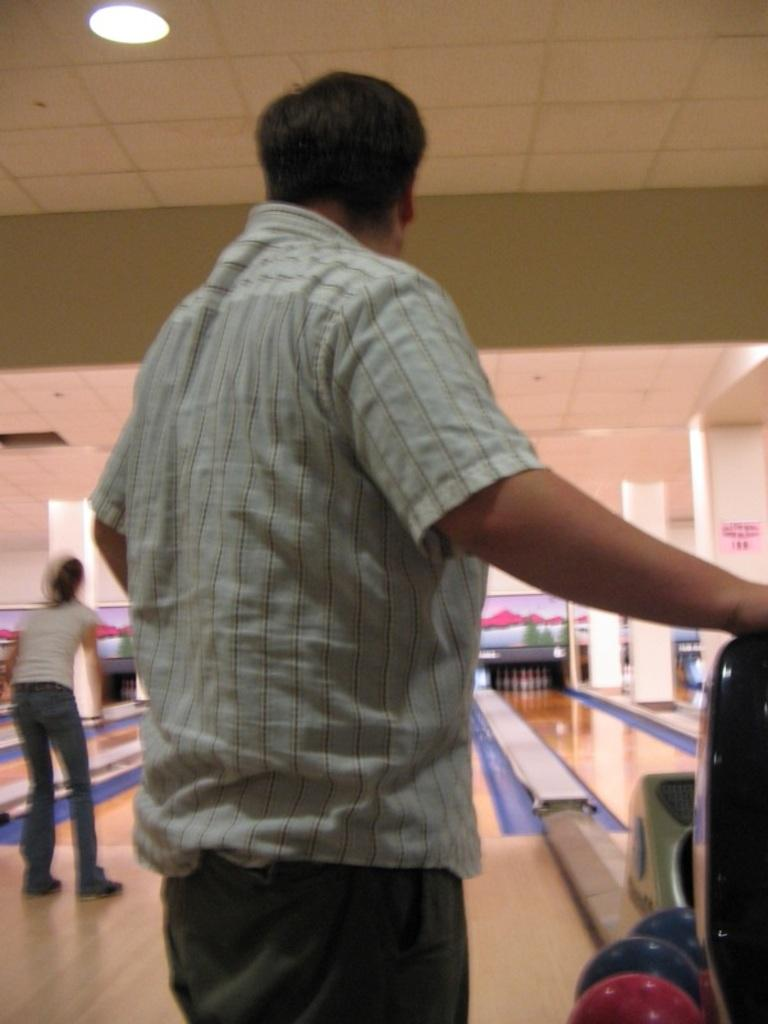How many people are in the foreground of the image? There are two persons in the foreground of the image. What are the two persons doing in the image? The two persons are playing a game on the floor. What can be seen in the background of the image? There is a wall and a rooftop in the background of the image. What is on the rooftop? Lights are mounted on the rooftop. Where was the image taken? The image was taken in a hall. What type of mark can be seen on the truck in the image? There are no trucks present in the image, so there is no mark to be seen on a truck. What kind of fang is visible on the person playing the game in the image? There are no fangs visible on the persons playing the game in the image. 